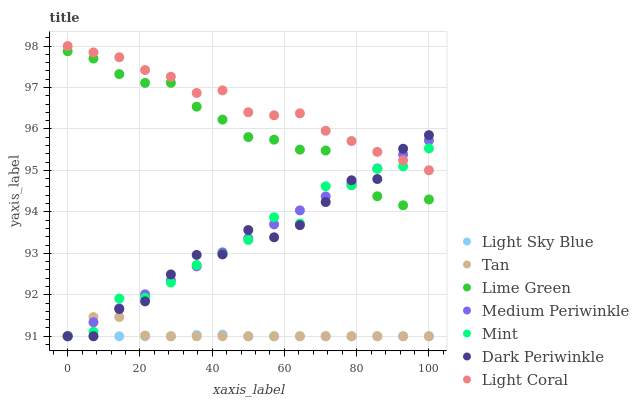Does Light Sky Blue have the minimum area under the curve?
Answer yes or no. Yes. Does Light Coral have the maximum area under the curve?
Answer yes or no. Yes. Does Medium Periwinkle have the minimum area under the curve?
Answer yes or no. No. Does Medium Periwinkle have the maximum area under the curve?
Answer yes or no. No. Is Medium Periwinkle the smoothest?
Answer yes or no. Yes. Is Mint the roughest?
Answer yes or no. Yes. Is Light Coral the smoothest?
Answer yes or no. No. Is Light Coral the roughest?
Answer yes or no. No. Does Mint have the lowest value?
Answer yes or no. Yes. Does Light Coral have the lowest value?
Answer yes or no. No. Does Light Coral have the highest value?
Answer yes or no. Yes. Does Medium Periwinkle have the highest value?
Answer yes or no. No. Is Tan less than Light Coral?
Answer yes or no. Yes. Is Lime Green greater than Light Sky Blue?
Answer yes or no. Yes. Does Dark Periwinkle intersect Light Coral?
Answer yes or no. Yes. Is Dark Periwinkle less than Light Coral?
Answer yes or no. No. Is Dark Periwinkle greater than Light Coral?
Answer yes or no. No. Does Tan intersect Light Coral?
Answer yes or no. No. 